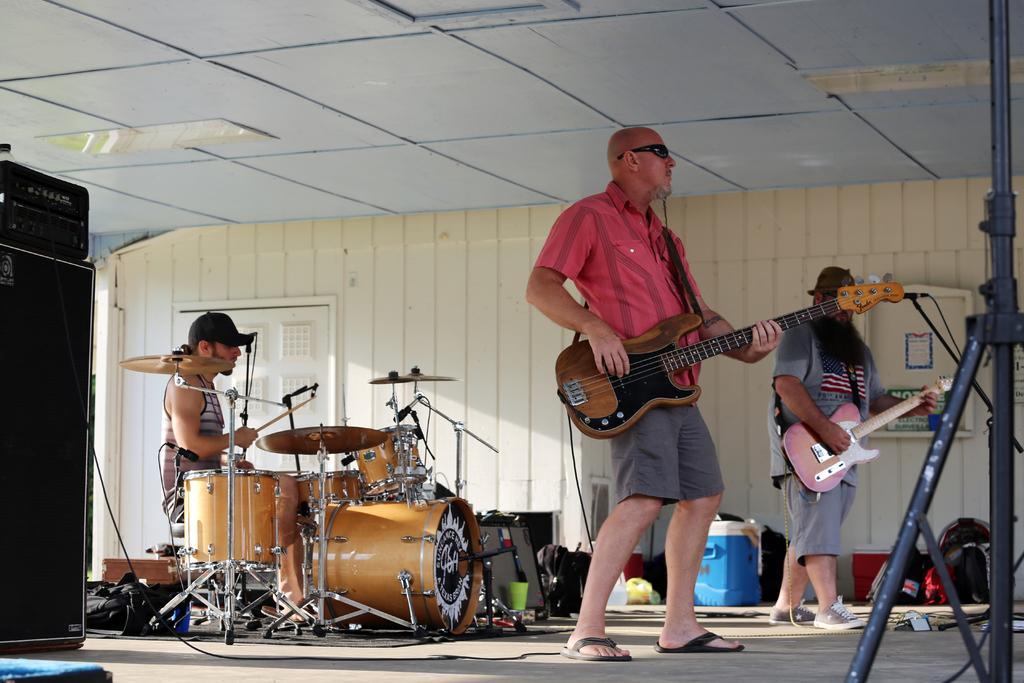In one or two sentences, can you explain what this image depicts? In the image we can see there is a man who is sitting and playing drums and in front of him there are two men who are holding guitar in their hands. 